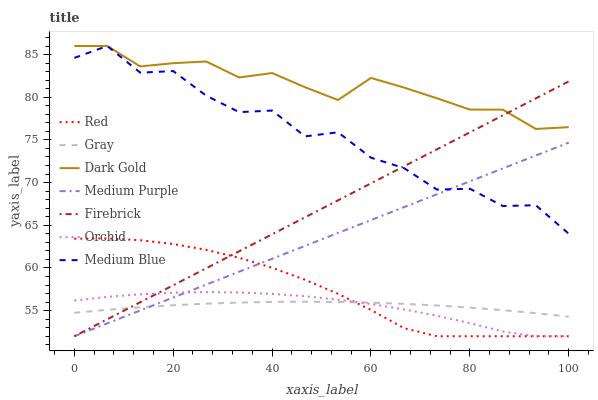Does Orchid have the minimum area under the curve?
Answer yes or no. Yes. Does Dark Gold have the maximum area under the curve?
Answer yes or no. Yes. Does Firebrick have the minimum area under the curve?
Answer yes or no. No. Does Firebrick have the maximum area under the curve?
Answer yes or no. No. Is Firebrick the smoothest?
Answer yes or no. Yes. Is Medium Blue the roughest?
Answer yes or no. Yes. Is Dark Gold the smoothest?
Answer yes or no. No. Is Dark Gold the roughest?
Answer yes or no. No. Does Firebrick have the lowest value?
Answer yes or no. Yes. Does Dark Gold have the lowest value?
Answer yes or no. No. Does Medium Blue have the highest value?
Answer yes or no. Yes. Does Firebrick have the highest value?
Answer yes or no. No. Is Orchid less than Medium Blue?
Answer yes or no. Yes. Is Medium Blue greater than Orchid?
Answer yes or no. Yes. Does Medium Purple intersect Medium Blue?
Answer yes or no. Yes. Is Medium Purple less than Medium Blue?
Answer yes or no. No. Is Medium Purple greater than Medium Blue?
Answer yes or no. No. Does Orchid intersect Medium Blue?
Answer yes or no. No. 